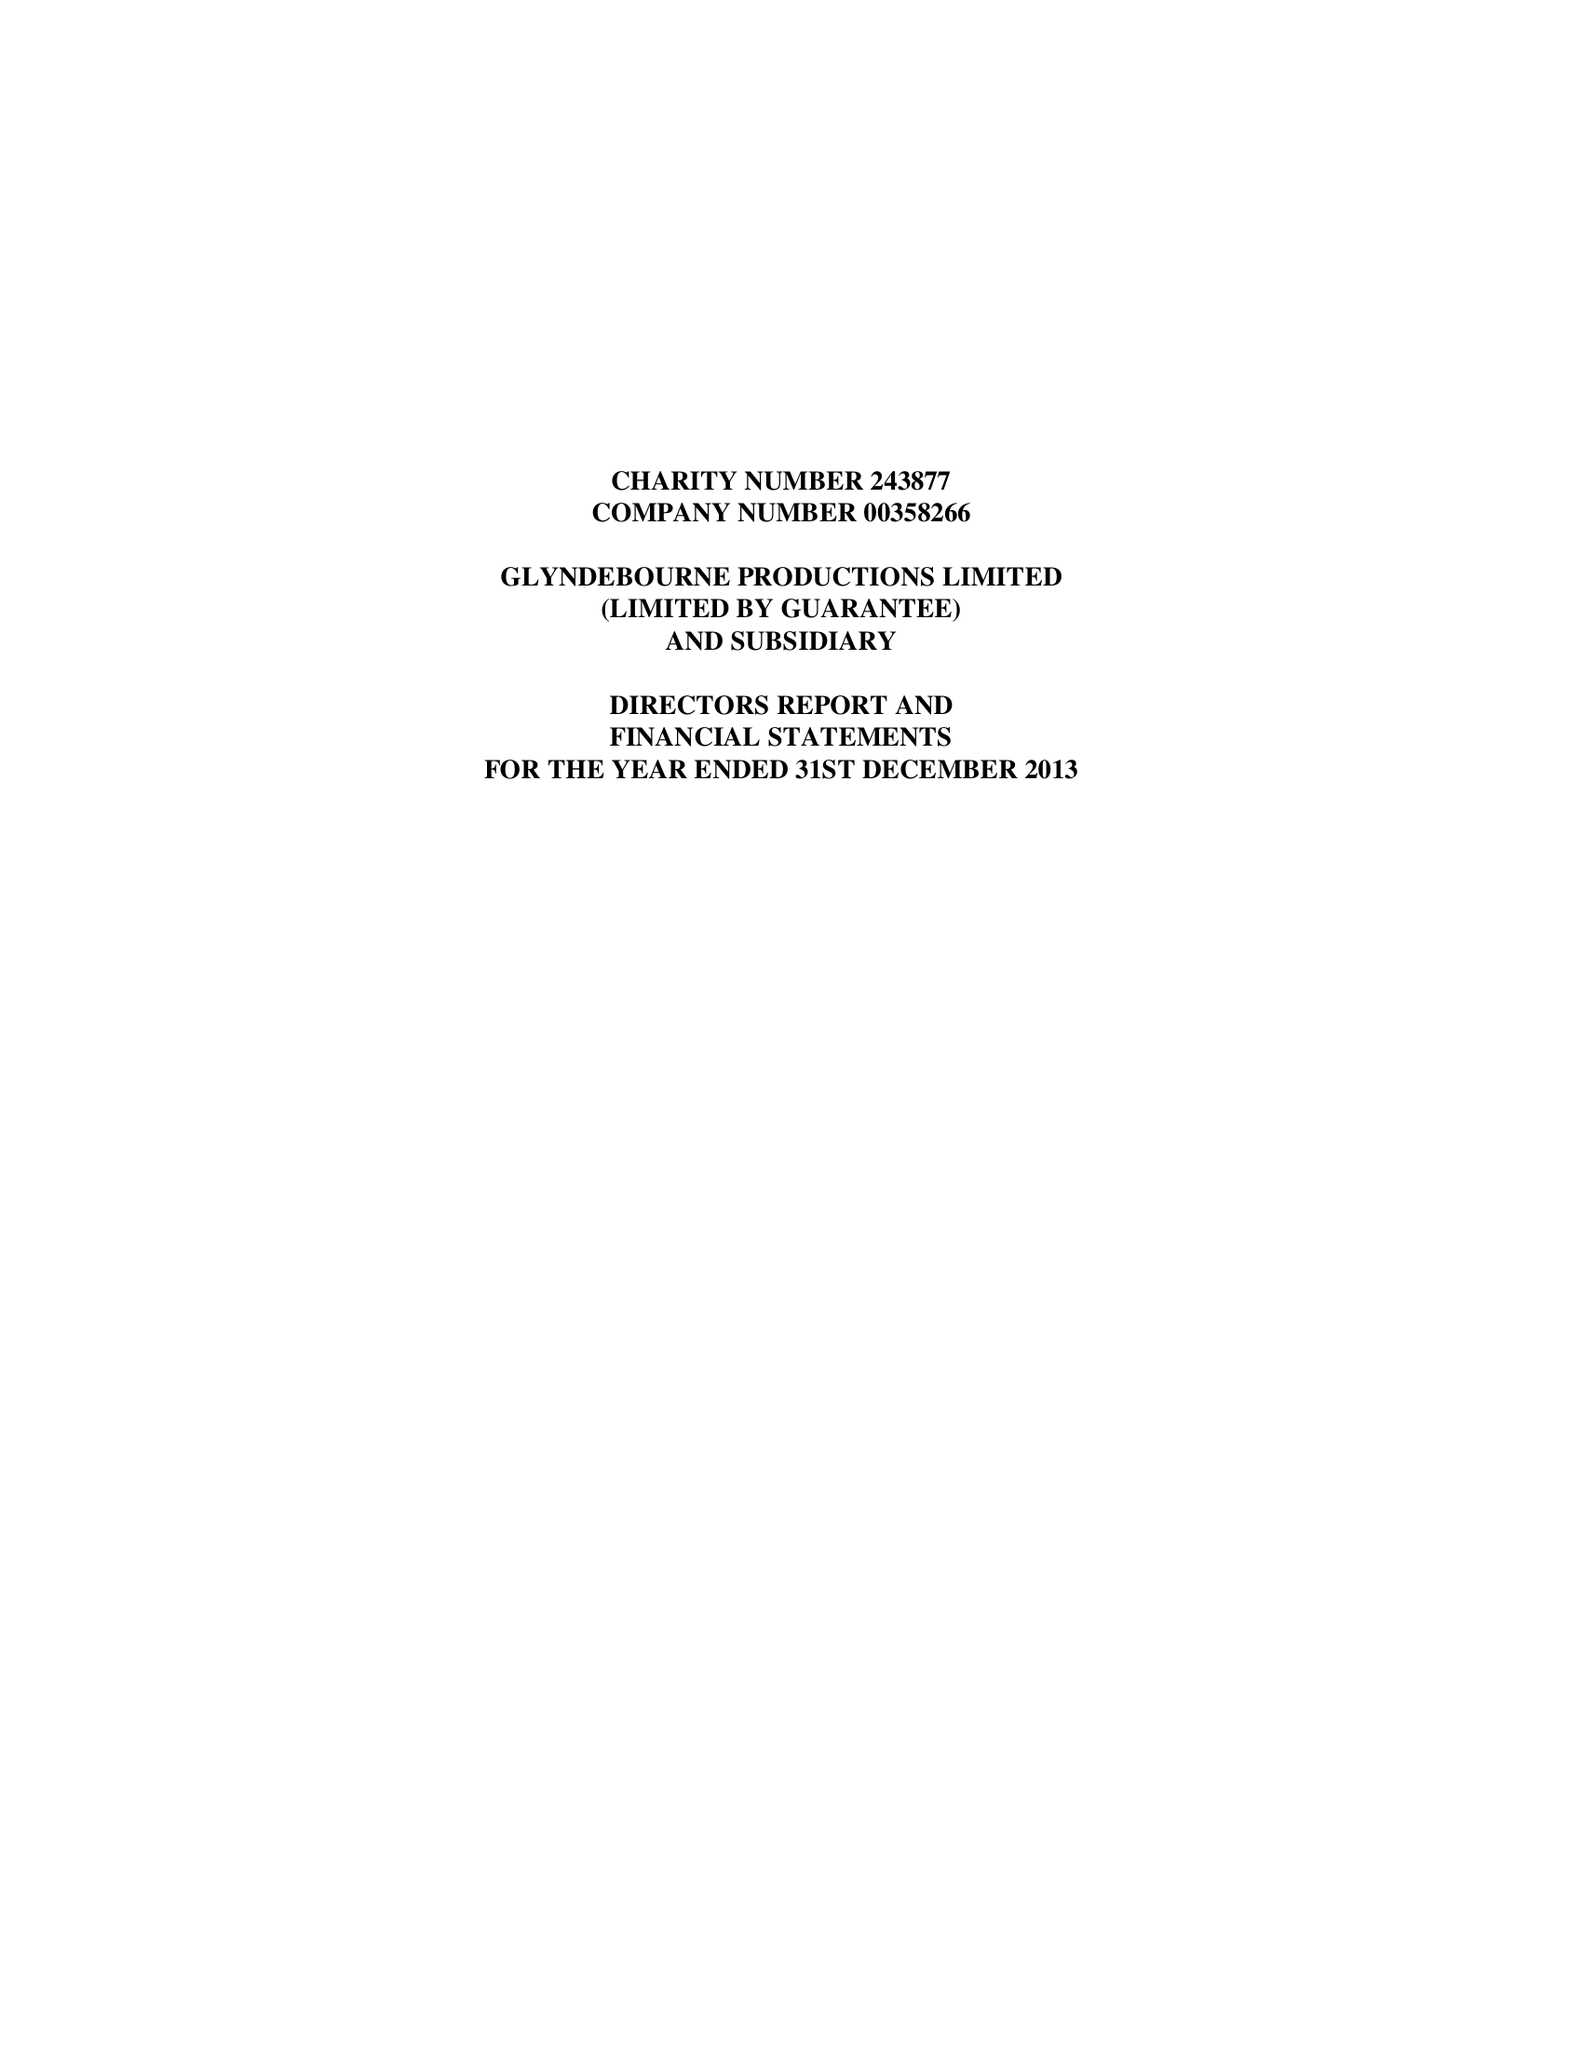What is the value for the address__street_line?
Answer the question using a single word or phrase. NEW ROAD 